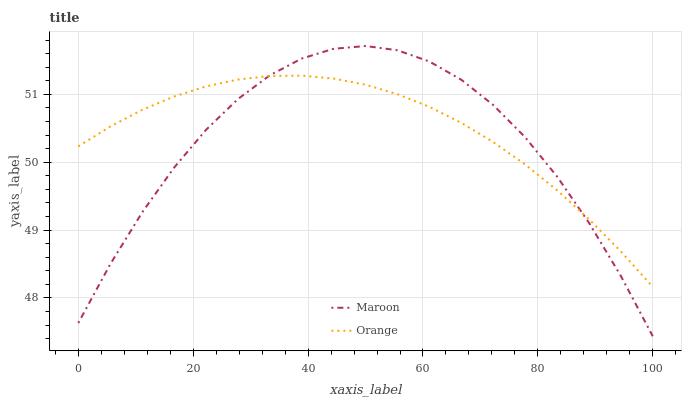Does Maroon have the minimum area under the curve?
Answer yes or no. Yes. Does Orange have the maximum area under the curve?
Answer yes or no. Yes. Does Maroon have the maximum area under the curve?
Answer yes or no. No. Is Orange the smoothest?
Answer yes or no. Yes. Is Maroon the roughest?
Answer yes or no. Yes. Is Maroon the smoothest?
Answer yes or no. No. Does Maroon have the lowest value?
Answer yes or no. Yes. Does Maroon have the highest value?
Answer yes or no. Yes. Does Orange intersect Maroon?
Answer yes or no. Yes. Is Orange less than Maroon?
Answer yes or no. No. Is Orange greater than Maroon?
Answer yes or no. No. 